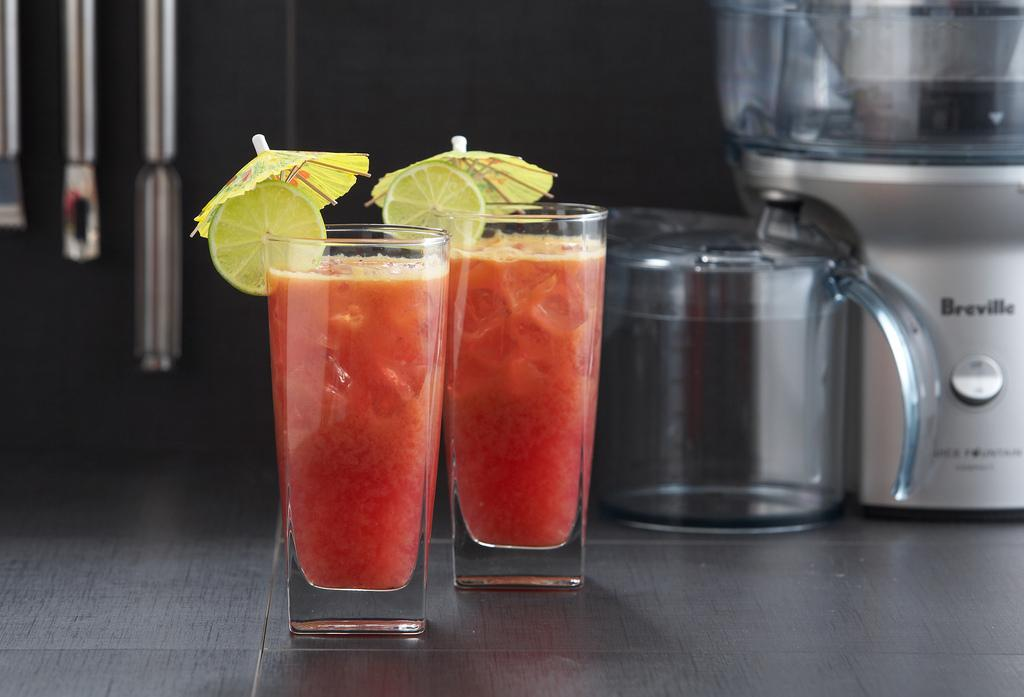Provide a one-sentence caption for the provided image. Two drinks with umbrellas with a Breville maker behind. 